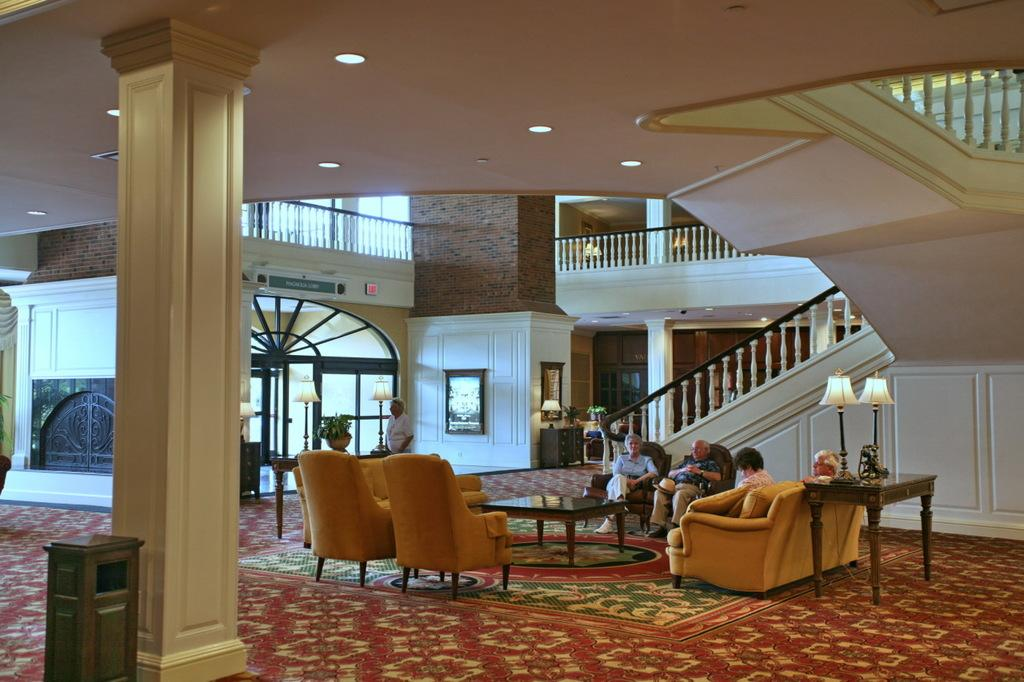What is the main subject of the image? The image depicts a building. Can you describe the scene inside the building? There are people sitting at a table in a room. What is the person near the lamp doing? There is a person standing near a lamp. What type of decorative items can be seen in the image? Frames are present in the image. What furniture is visible in the image? There is a table in the image. Are there any architectural features visible in the image? A staircase and pillars are present in the image. What type of barrier is present in the image? There is a fence in the image. What type of animal can be seen sleeping on the table in the image? There is no animal present in the image, let alone sleeping on the table. 